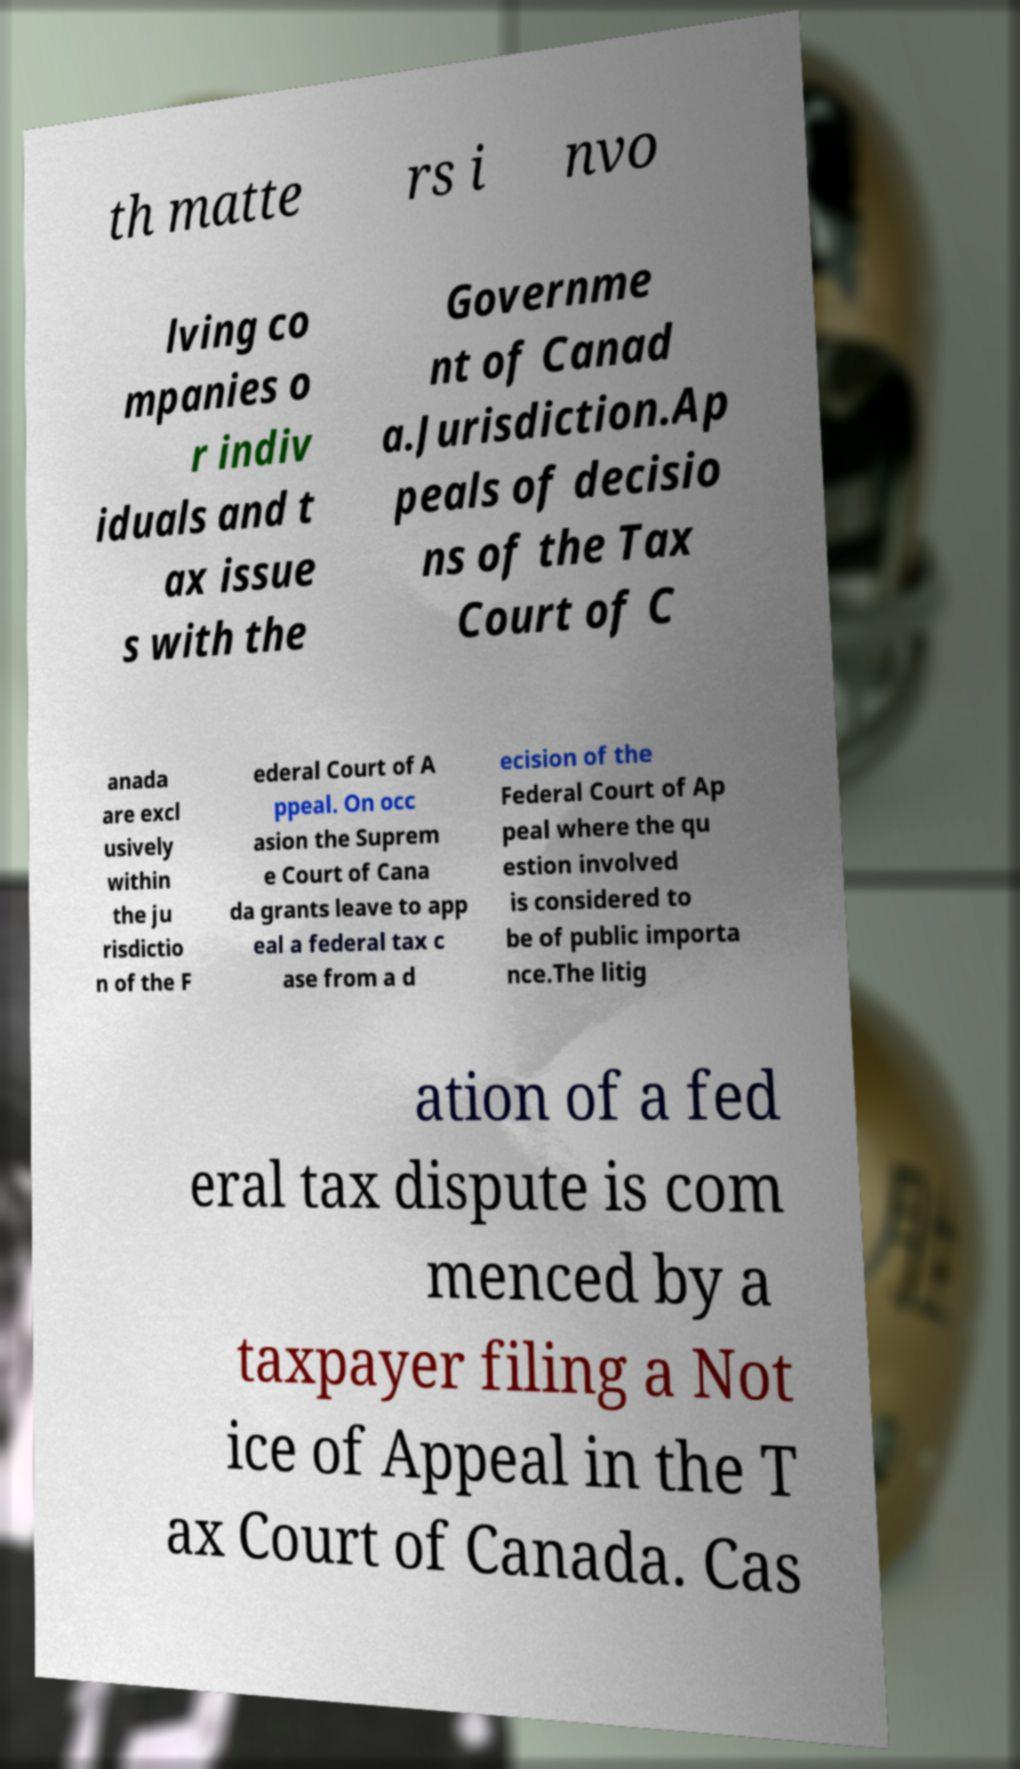I need the written content from this picture converted into text. Can you do that? th matte rs i nvo lving co mpanies o r indiv iduals and t ax issue s with the Governme nt of Canad a.Jurisdiction.Ap peals of decisio ns of the Tax Court of C anada are excl usively within the ju risdictio n of the F ederal Court of A ppeal. On occ asion the Suprem e Court of Cana da grants leave to app eal a federal tax c ase from a d ecision of the Federal Court of Ap peal where the qu estion involved is considered to be of public importa nce.The litig ation of a fed eral tax dispute is com menced by a taxpayer filing a Not ice of Appeal in the T ax Court of Canada. Cas 